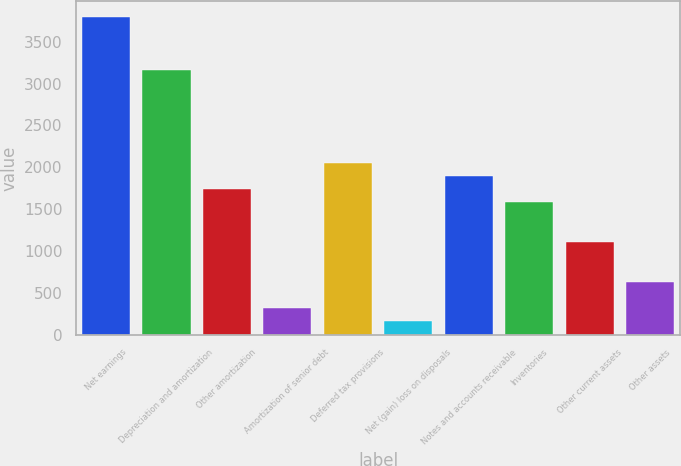Convert chart to OTSL. <chart><loc_0><loc_0><loc_500><loc_500><bar_chart><fcel>Net earnings<fcel>Depreciation and amortization<fcel>Other amortization<fcel>Amortization of senior debt<fcel>Deferred tax provisions<fcel>Net (gain) loss on disposals<fcel>Notes and accounts receivable<fcel>Inventories<fcel>Other current assets<fcel>Other assets<nl><fcel>3795.68<fcel>3163.2<fcel>1740.12<fcel>317.04<fcel>2056.36<fcel>158.92<fcel>1898.24<fcel>1582<fcel>1107.64<fcel>633.28<nl></chart> 